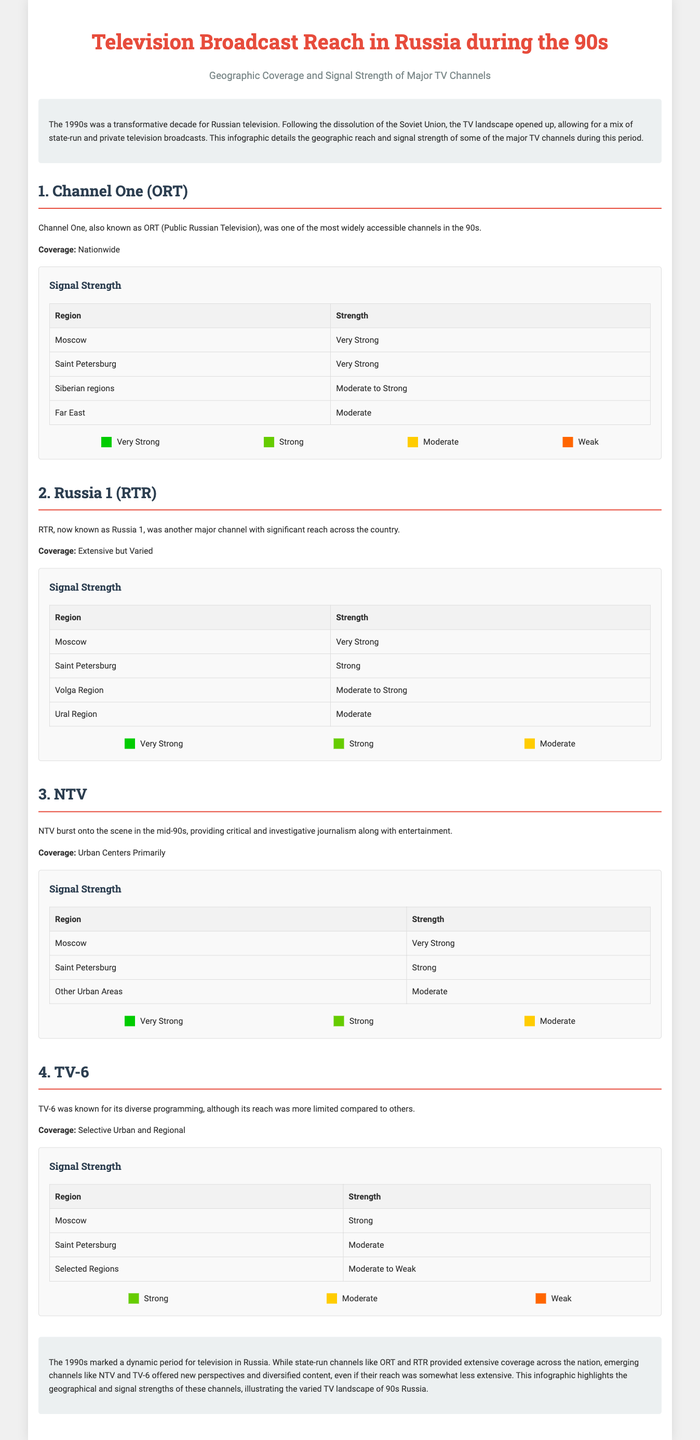What is the coverage area of Channel One (ORT)? Channel One's coverage area is described as nationwide in the document.
Answer: Nationwide What was the signal strength of NTV in Moscow? The document states that the signal strength of NTV in Moscow was very strong.
Answer: Very Strong Which channel was known for its critical and investigative journalism? The document specifies that NTV burst onto the scene providing critical and investigative journalism.
Answer: NTV How does the signal strength of Russia 1 (RTR) in the Ural Region compare to other regions? The signal strength in the Ural Region is stated as moderate, which is lower than Moscow and Saint Petersburg.
Answer: Moderate Which channel had selective urban and regional coverage? The document mentions that TV-6 had selective urban and regional coverage.
Answer: TV-6 What was the overall signal strength coverage of Channel One (ORT) in the Far East? The document indicates that the signal strength in the Far East was moderate.
Answer: Moderate How many channels are detailed in the document? The number of channels mentioned is four: Channel One, Russia 1, NTV, and TV-6.
Answer: Four What color represents "Very Strong" in the signal strength legend? The document shows the color green representing "Very Strong" in the legend.
Answer: Green What city had “Strong” signal strength for TV-6? The document specifies that the signal strength in Saint Petersburg for TV-6 was moderate.
Answer: Saint Petersburg 